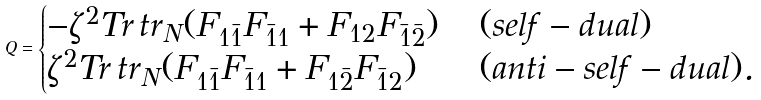Convert formula to latex. <formula><loc_0><loc_0><loc_500><loc_500>Q = \begin{cases} - \zeta ^ { 2 } T r \, t r _ { N } ( F _ { 1 \bar { 1 } } F _ { \bar { 1 } 1 } + F _ { 1 2 } F _ { \bar { 1 } \bar { 2 } } ) \, & ( s e l f - d u a l ) \\ \zeta ^ { 2 } T r \, t r _ { N } ( F _ { 1 \bar { 1 } } F _ { \bar { 1 } 1 } + F _ { 1 \bar { 2 } } F _ { \bar { 1 } 2 } ) \, & ( a n t i - s e l f - d u a l ) . \end{cases}</formula> 